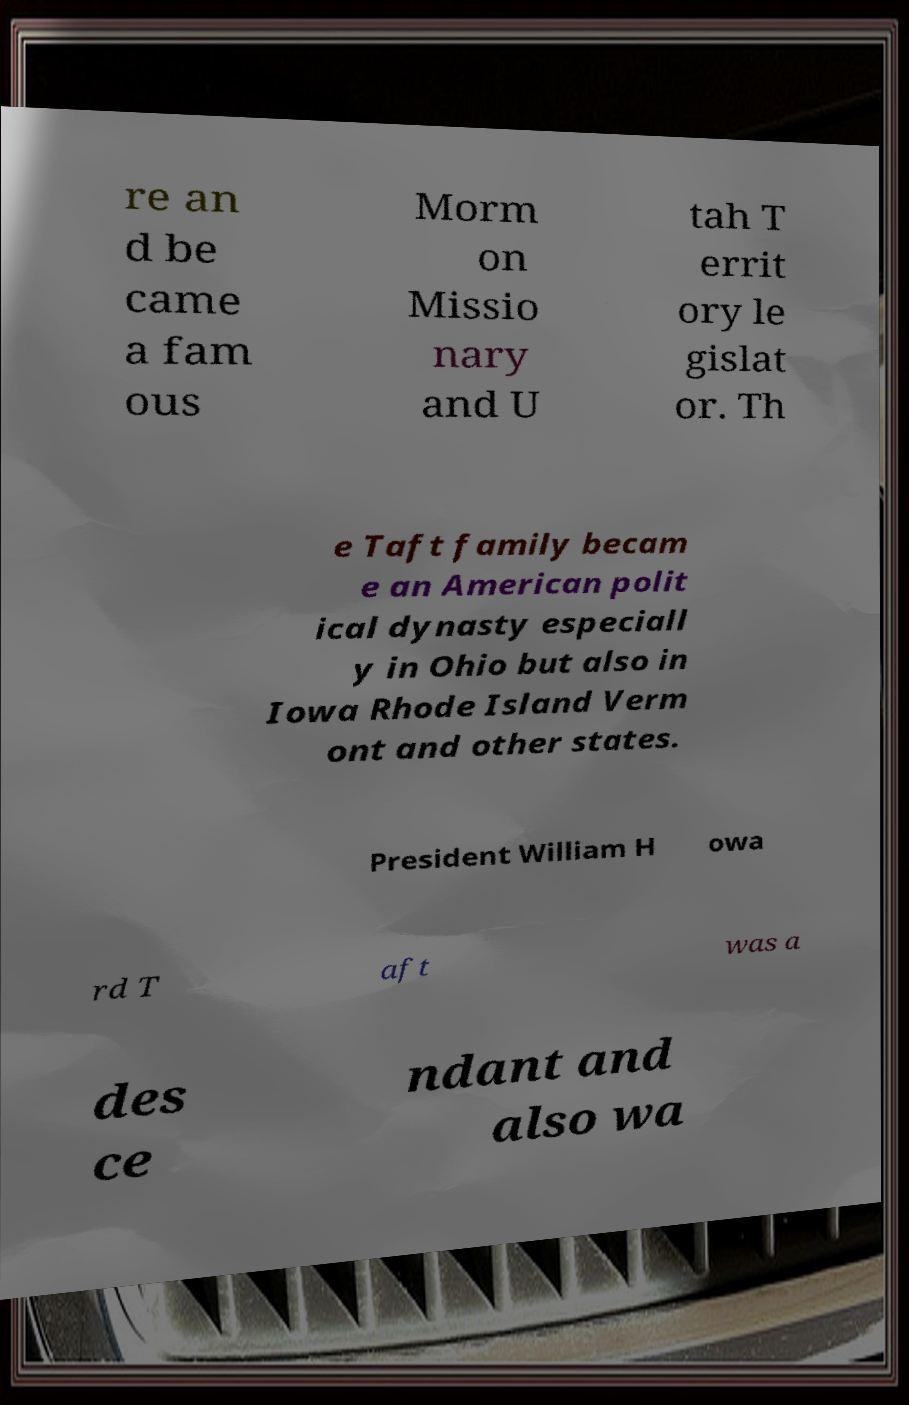What messages or text are displayed in this image? I need them in a readable, typed format. re an d be came a fam ous Morm on Missio nary and U tah T errit ory le gislat or. Th e Taft family becam e an American polit ical dynasty especiall y in Ohio but also in Iowa Rhode Island Verm ont and other states. President William H owa rd T aft was a des ce ndant and also wa 